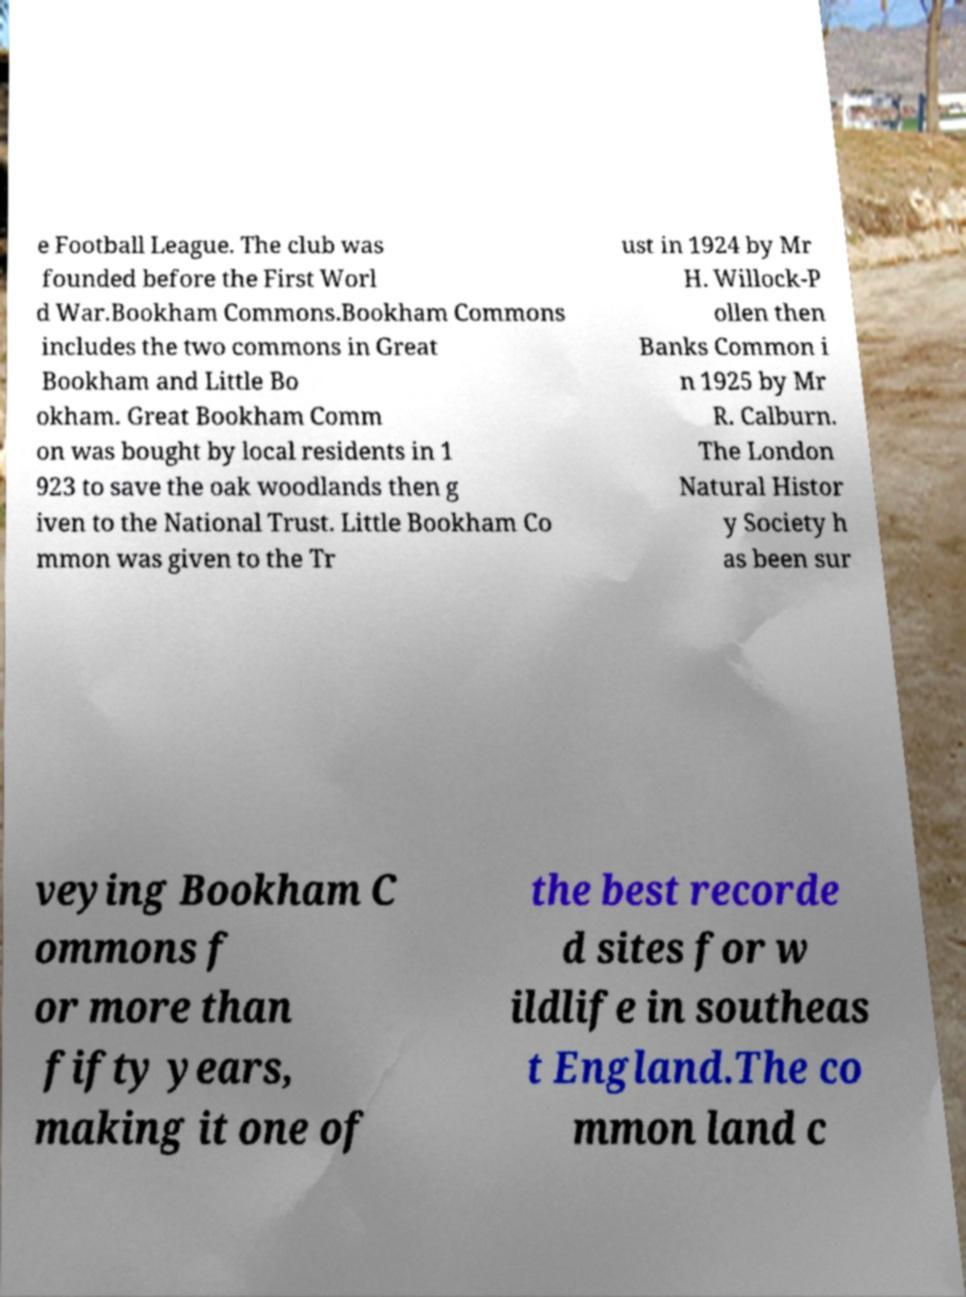What messages or text are displayed in this image? I need them in a readable, typed format. e Football League. The club was founded before the First Worl d War.Bookham Commons.Bookham Commons includes the two commons in Great Bookham and Little Bo okham. Great Bookham Comm on was bought by local residents in 1 923 to save the oak woodlands then g iven to the National Trust. Little Bookham Co mmon was given to the Tr ust in 1924 by Mr H. Willock-P ollen then Banks Common i n 1925 by Mr R. Calburn. The London Natural Histor y Society h as been sur veying Bookham C ommons f or more than fifty years, making it one of the best recorde d sites for w ildlife in southeas t England.The co mmon land c 